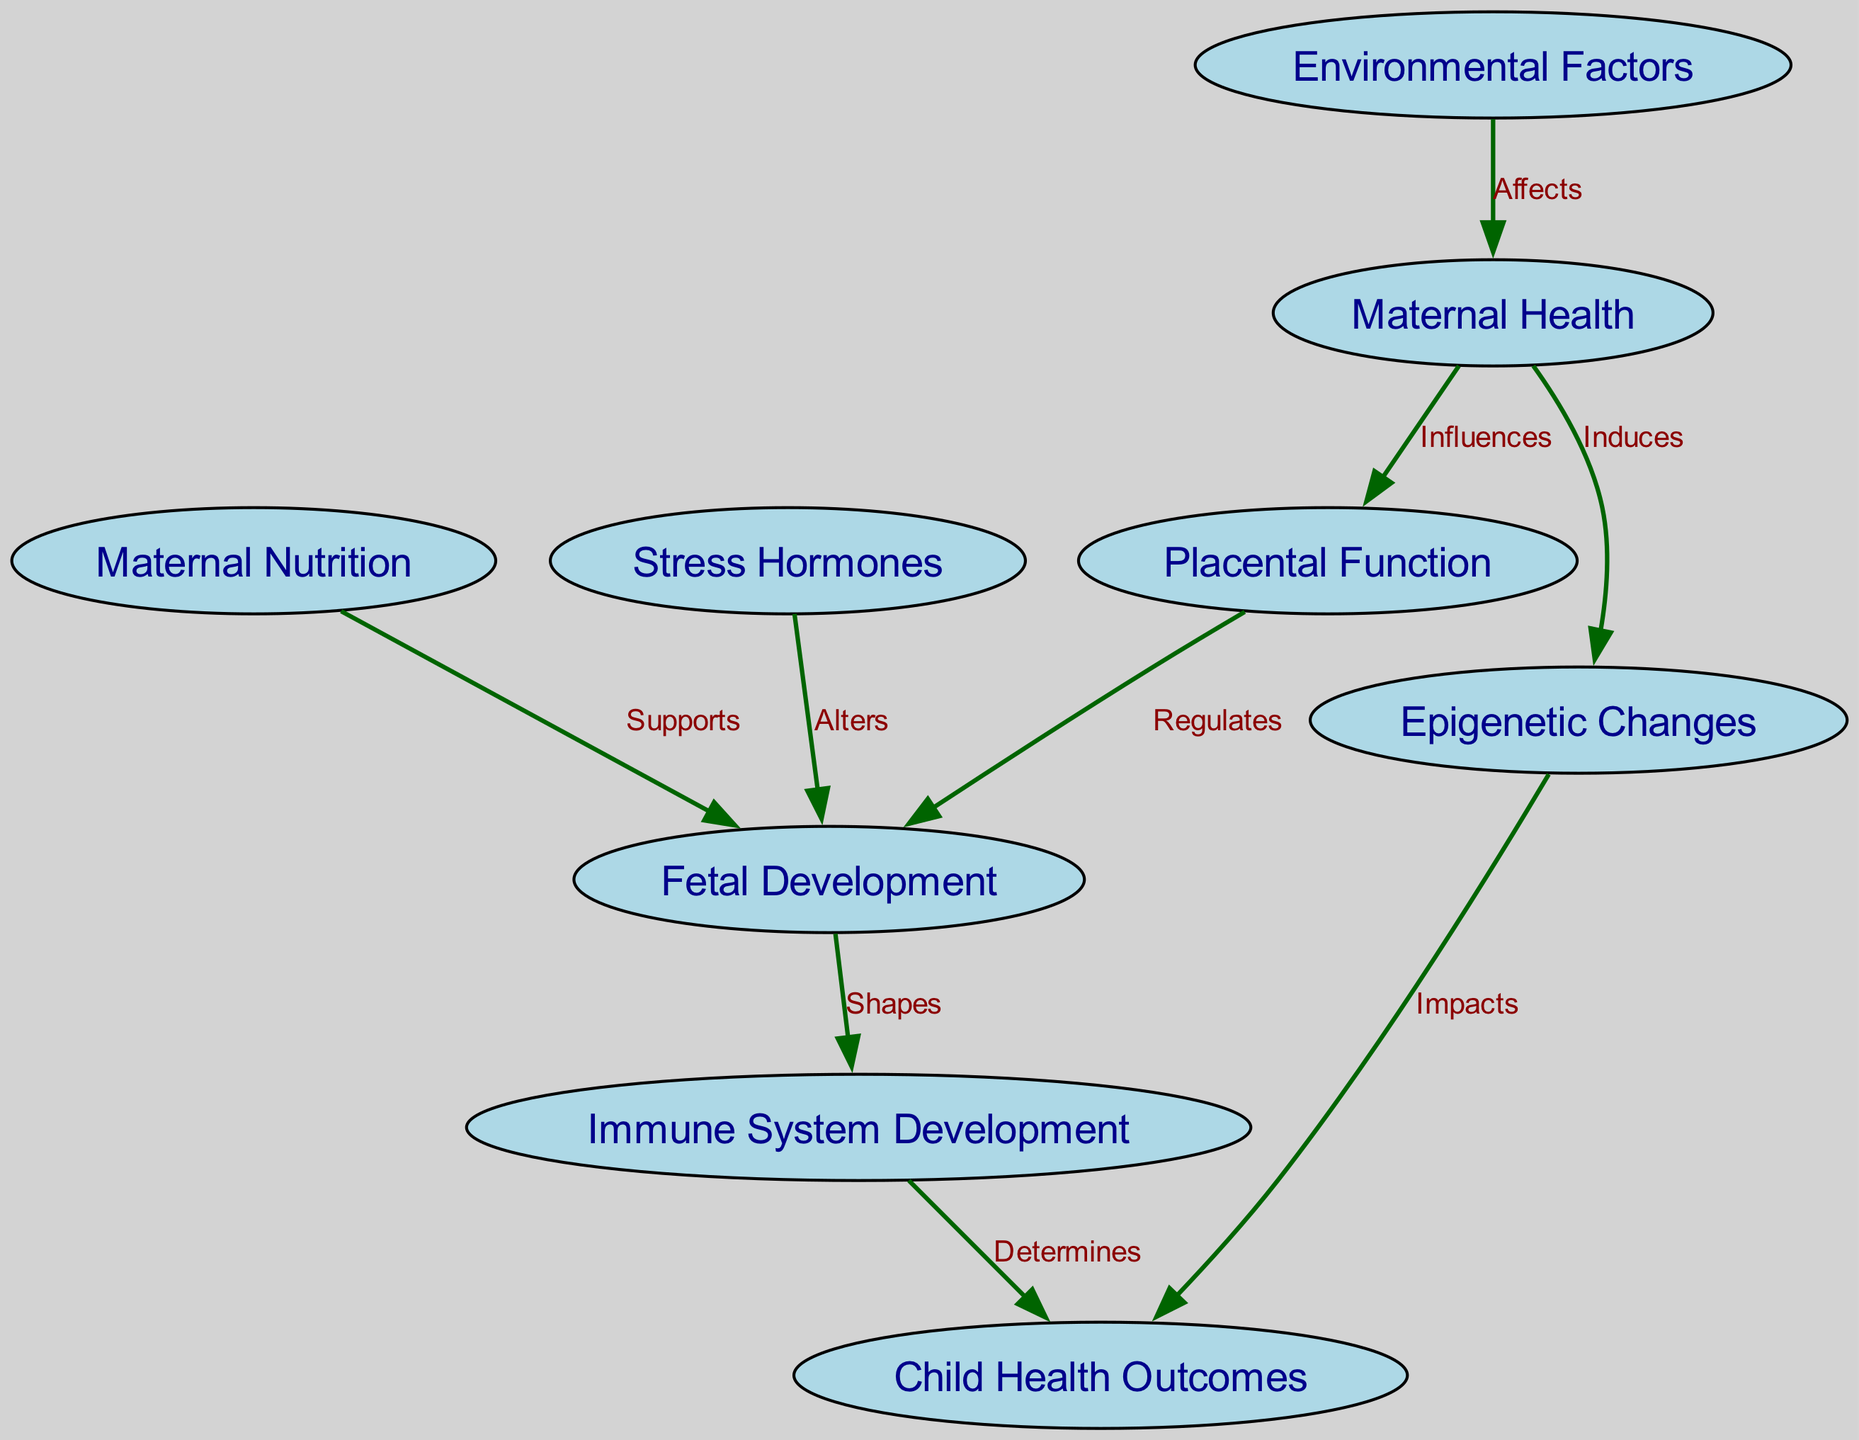what are the total number of nodes in the diagram? The diagram includes a list of nodes representing key concepts, which can be counted. Looking at the provided data, there are 8 distinct nodes mentioned.
Answer: 8 what is the relationship between Maternal Health and Placental Function? In the directed graph, the edge from Maternal Health to Placental Function is labeled "Influences," indicating a direct influence of maternal health on placental function.
Answer: Influences which node indicates the impact on Child Health Outcomes through Epigenetic Changes? The edge from Epigenetic Changes to Child Health Outcomes is labeled "Impacts," indicating that epigenetic changes impact child health outcomes in the graph.
Answer: Impacts how many edges are there in total? By examining the provided data, the number of directed edges that describe relationships between the nodes can be counted. There are a total of 9 edges mentioned.
Answer: 9 what does Fetal Development shape? The diagram shows that Fetal Development has a directed connection to Immune System Development, indicating that it shapes this aspect of development.
Answer: Immune System Development which factor influences Maternal Health according to the diagram? The arrow from Environmental Factors to Maternal Health, labeled "Affects," indicates that environmental factors influence maternal health.
Answer: Affects what is the direct consequence of Stress Hormones on Fetal Development? The directed edge from Stress Hormones to Fetal Development is labeled "Alters," indicating that stress hormones alter fetal development.
Answer: Alters which two nodes are related by the label "Supports"? The edge from Maternal Nutrition to Fetal Development is labeled "Supports," indicating a supportive relationship between these two nodes.
Answer: Supports what is the final outcome that is determined by Immune System Development? The directed edge leading from Immune System Development to Child Health Outcomes indicates that it determines child health outcomes in the diagram.
Answer: Determines 